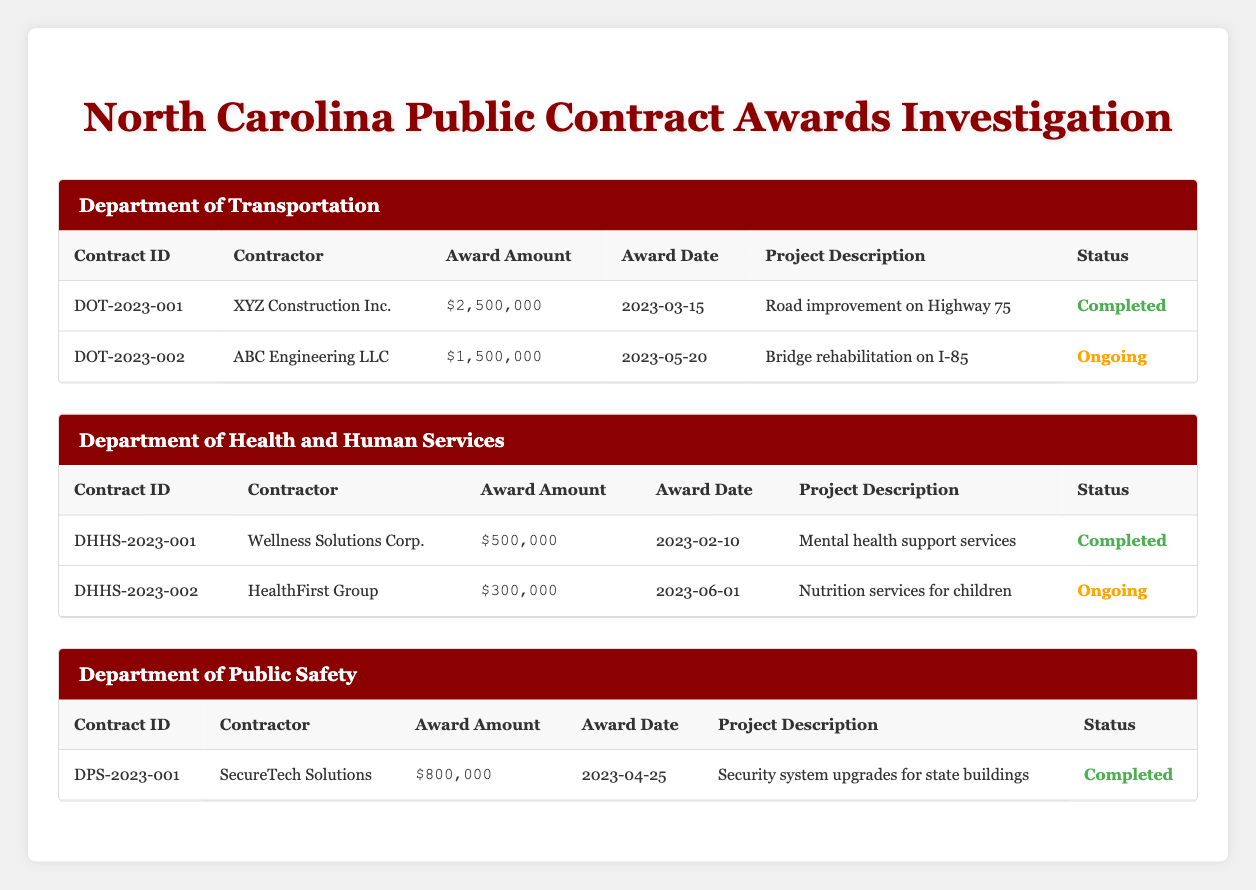What is the total award amount for contracts in the Department of Transportation? The Department of Transportation has two contracts. The first contract (DOT-2023-001) is for $2,500,000 and the second contract (DOT-2023-002) is for $1,500,000. Adding these amounts together gives $2,500,000 + $1,500,000 = $4,000,000.
Answer: $4,000,000 Which contractor was awarded the highest amount? To determine the contractor with the highest award amount, we compare the award amounts of all contracts listed. The highest award amount is for the contractor XYZ Construction Inc. with $2,500,000 for contract DOT-2023-001.
Answer: XYZ Construction Inc Is the contract with ID DHHS-2023-002 completed? The status of contract DHHS-2023-002 indicates that it is ongoing. Therefore, it is not completed.
Answer: No How many contracts are ongoing across all departments? There are two contracts marked as ongoing: one in the Department of Transportation (DOT-2023-002) and one in the Department of Health and Human Services (DHHS-2023-002). This adds up to a total of two ongoing contracts across all departments.
Answer: 2 What is the average award amount for contracts in the Department of Health and Human Services? The Department of Health and Human Services has two contracts with award amounts of $500,000 and $300,000. The total award amount is $500,000 + $300,000 = $800,000. There are 2 contracts, so the average is $800,000 / 2 = $400,000.
Answer: $400,000 Which agency has awarded the least total amount? The Department of Health and Human Services has a total award amount of $800,000. The Department of Public Safety awarded $800,000 as well, but only has one contract. The Department of Transportation awarded a total of $4,000,000. Thus, the two departments with $800,000 are the lowest.
Answer: Department of Health and Human Services and Department of Public Safety Are all contracts in the Department of Public Safety completed? There is one contract listed in the Department of Public Safety (DPS-2023-001), and it is marked as completed. Therefore, we can say yes, all contracts in that department are completed.
Answer: Yes What is the total number of contracts awarded by all departments? The Department of Transportation has 2 contracts, the Department of Health and Human Services has 2 contracts, and the Department of Public Safety has 1 contract. Summing these gives 2 + 2 + 1 = 5 contracts in total.
Answer: 5 